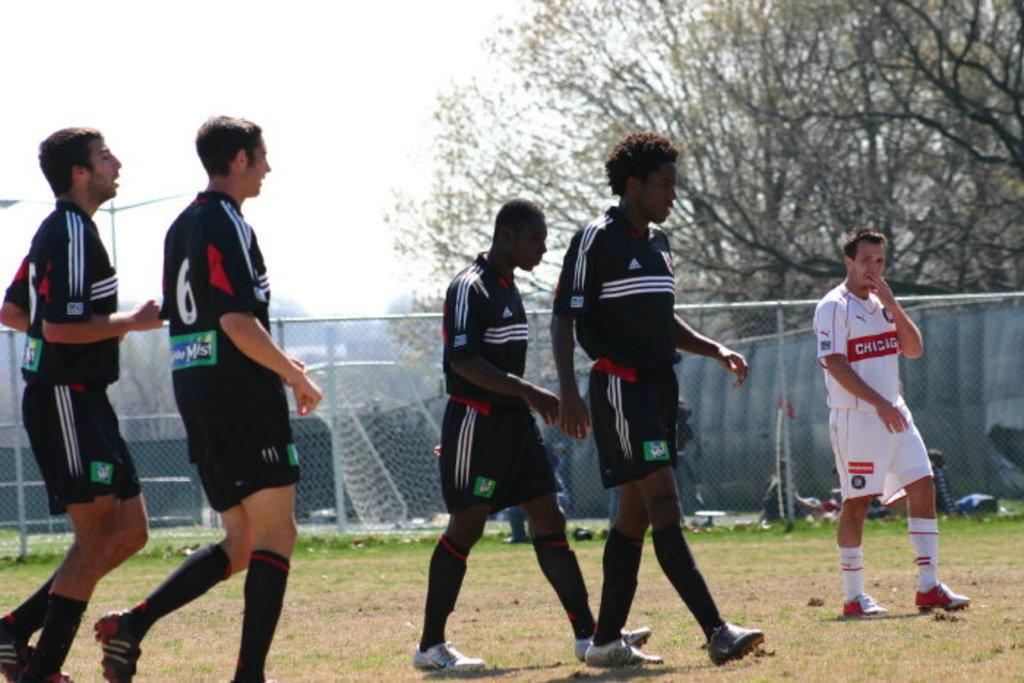Provide a one-sentence caption for the provided image. Soccer players wearing Adidas and the Goalie wearing a Chigig jersey. 